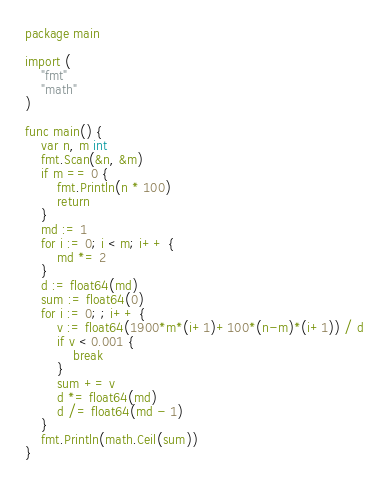<code> <loc_0><loc_0><loc_500><loc_500><_Go_>package main

import (
	"fmt"
	"math"
)

func main() {
	var n, m int
	fmt.Scan(&n, &m)
	if m == 0 {
		fmt.Println(n * 100)
		return
	}
	md := 1
	for i := 0; i < m; i++ {
		md *= 2
	}
	d := float64(md)
	sum := float64(0)
	for i := 0; ; i++ {
		v := float64(1900*m*(i+1)+100*(n-m)*(i+1)) / d
		if v < 0.001 {
			break
		}
		sum += v
		d *= float64(md)
		d /= float64(md - 1)
	}
	fmt.Println(math.Ceil(sum))
}
</code> 